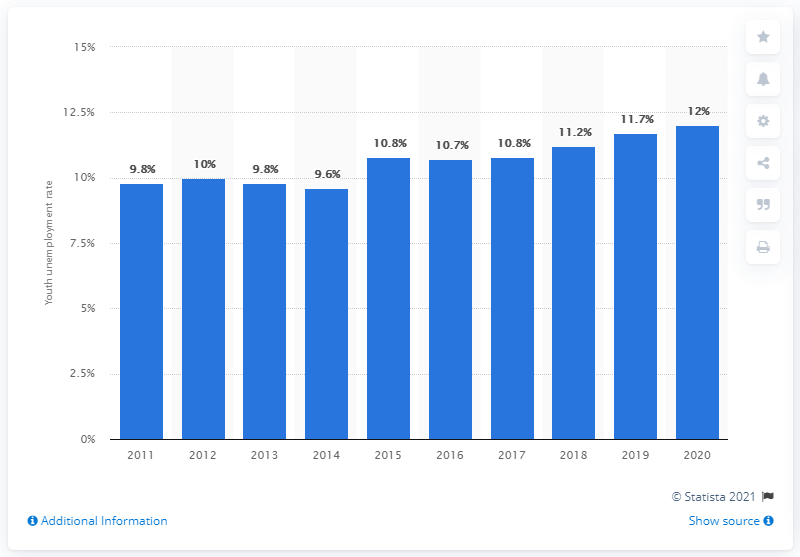Mention a couple of crucial points in this snapshot. The youth unemployment rate in Malaysia in 2020 was 12%. Since 2015, the youth unemployment rate in Malaysia has been increasing. 